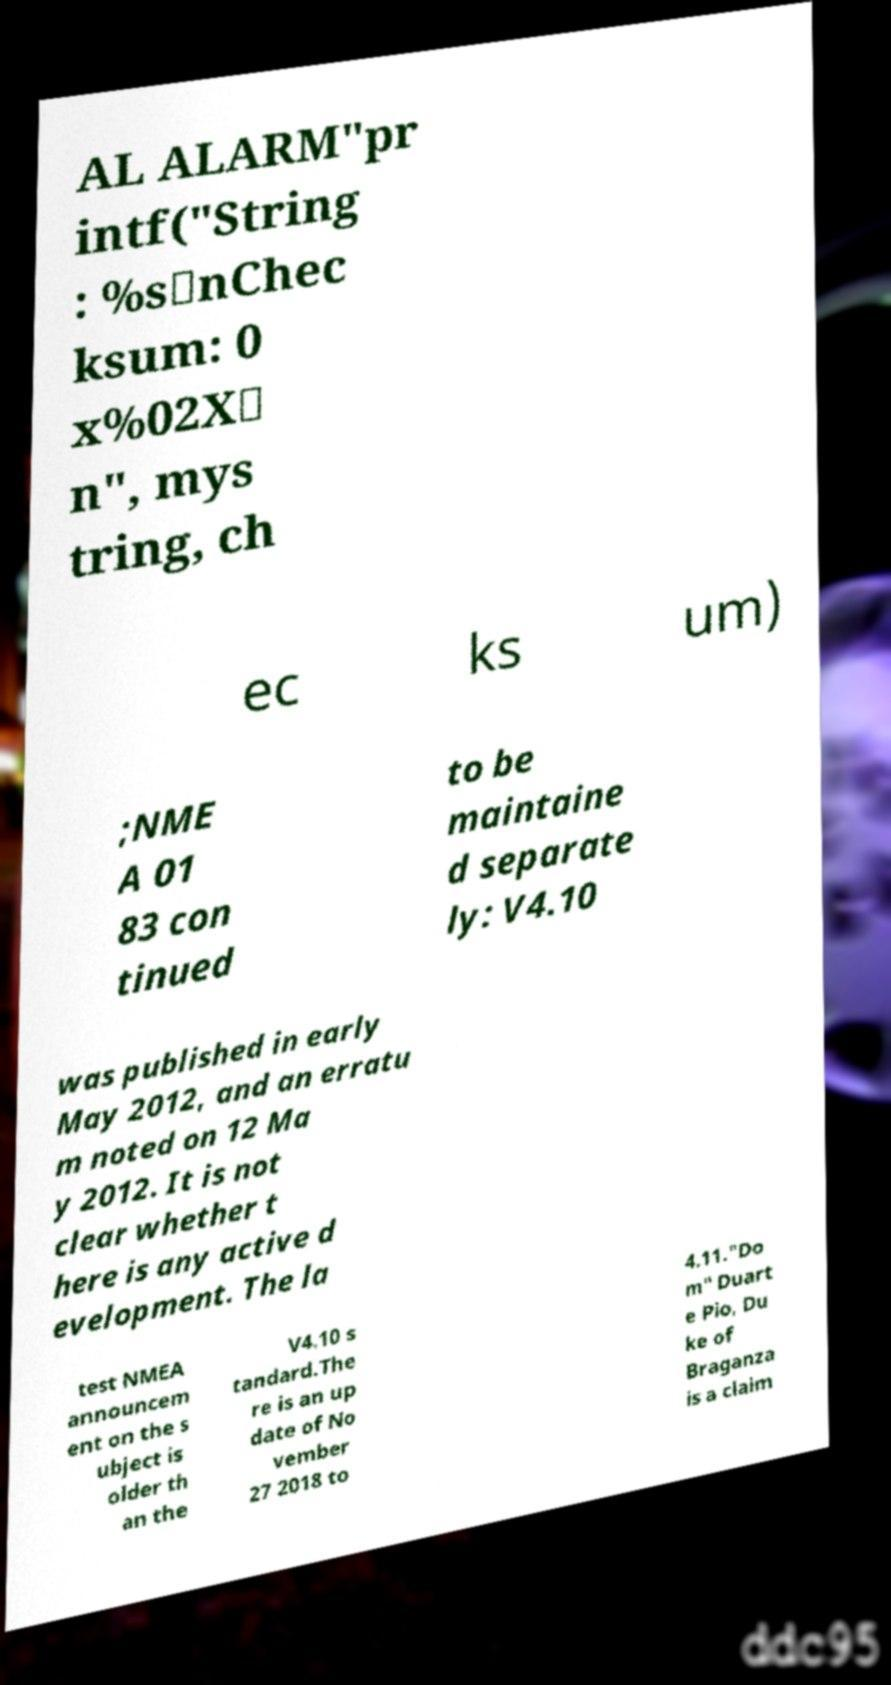I need the written content from this picture converted into text. Can you do that? AL ALARM"pr intf("String : %s\nChec ksum: 0 x%02X\ n", mys tring, ch ec ks um) ;NME A 01 83 con tinued to be maintaine d separate ly: V4.10 was published in early May 2012, and an erratu m noted on 12 Ma y 2012. It is not clear whether t here is any active d evelopment. The la test NMEA announcem ent on the s ubject is older th an the V4.10 s tandard.The re is an up date of No vember 27 2018 to 4.11."Do m" Duart e Pio, Du ke of Braganza is a claim 